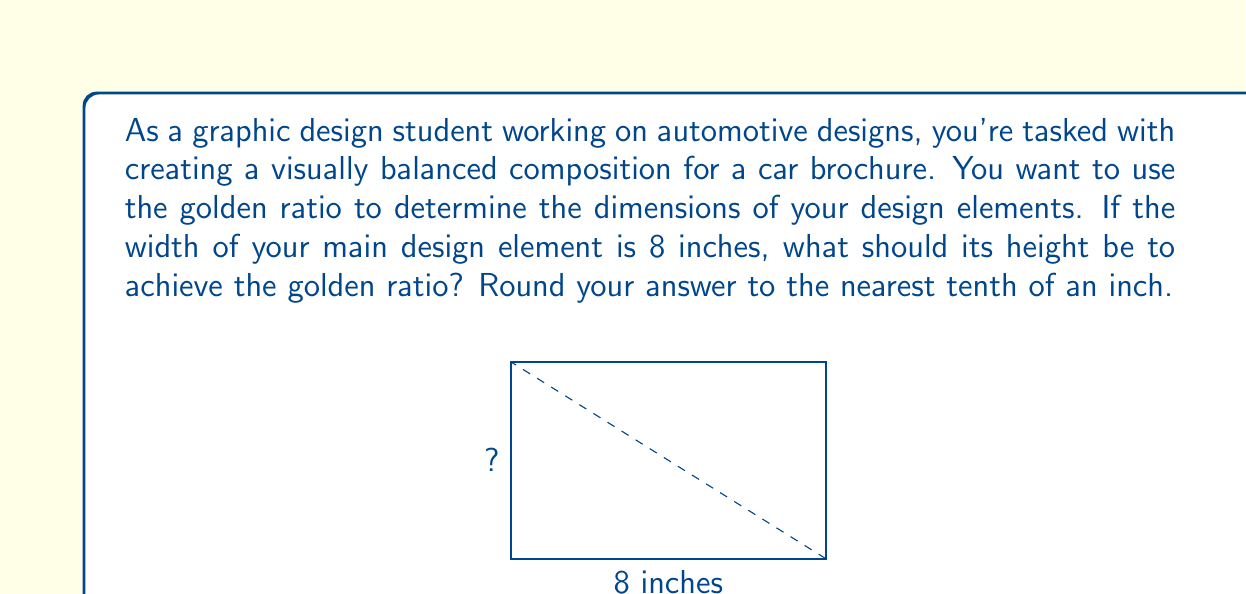Solve this math problem. To solve this problem, we need to follow these steps:

1) The golden ratio, denoted by φ (phi), is approximately equal to 1.618033988749895...

2) In a golden rectangle, the ratio of the longer side to the shorter side is equal to φ.

3) Let's denote the height as h. We can set up the following equation:

   $$\frac{8}{h} = φ$$

4) To find h, we need to solve this equation:

   $$h = \frac{8}{φ}$$

5) Substituting the value of φ:

   $$h = \frac{8}{1.618033988749895...}$$

6) Using a calculator or computer:

   $$h ≈ 4.944271909999159...$$

7) Rounding to the nearest tenth:

   $$h ≈ 4.9 \text{ inches}$$

Therefore, to achieve the golden ratio, the height of the design element should be approximately 4.9 inches.
Answer: 4.9 inches 